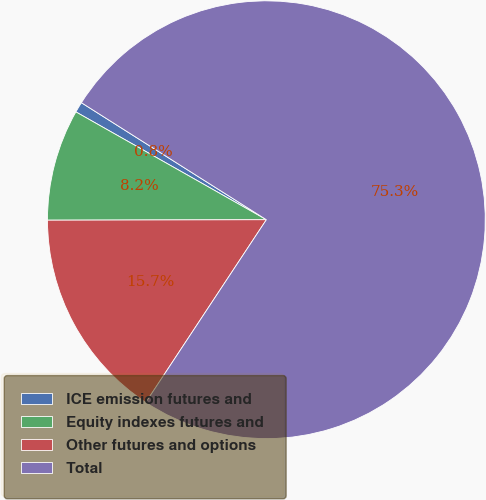Convert chart to OTSL. <chart><loc_0><loc_0><loc_500><loc_500><pie_chart><fcel>ICE emission futures and<fcel>Equity indexes futures and<fcel>Other futures and options<fcel>Total<nl><fcel>0.78%<fcel>8.23%<fcel>15.68%<fcel>75.3%<nl></chart> 